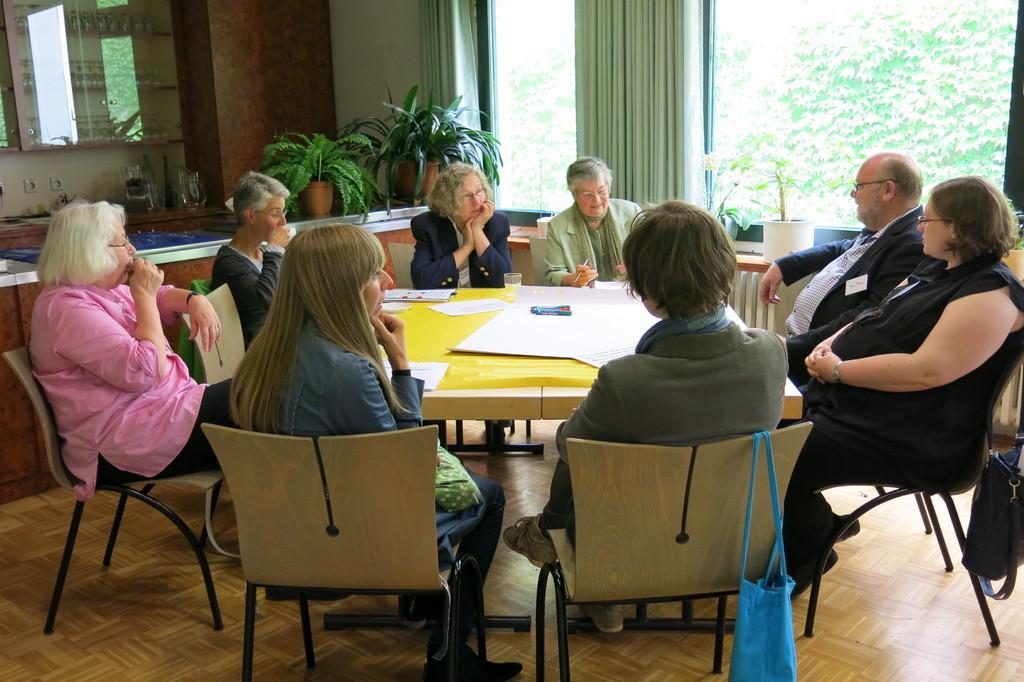Could you give a brief overview of what you see in this image? As we can see in the image there is a wall, window, curtain, plants, few people sitting on chairs and there is a table. On table there is a glass and paper. 